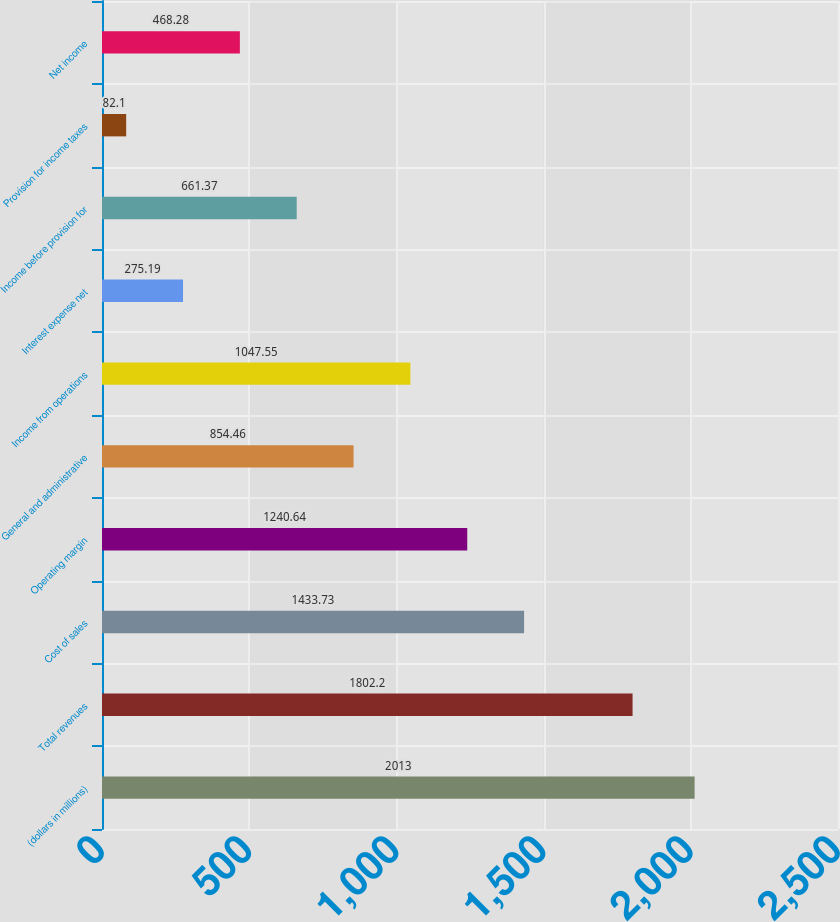Convert chart to OTSL. <chart><loc_0><loc_0><loc_500><loc_500><bar_chart><fcel>(dollars in millions)<fcel>Total revenues<fcel>Cost of sales<fcel>Operating margin<fcel>General and administrative<fcel>Income from operations<fcel>Interest expense net<fcel>Income before provision for<fcel>Provision for income taxes<fcel>Net income<nl><fcel>2013<fcel>1802.2<fcel>1433.73<fcel>1240.64<fcel>854.46<fcel>1047.55<fcel>275.19<fcel>661.37<fcel>82.1<fcel>468.28<nl></chart> 